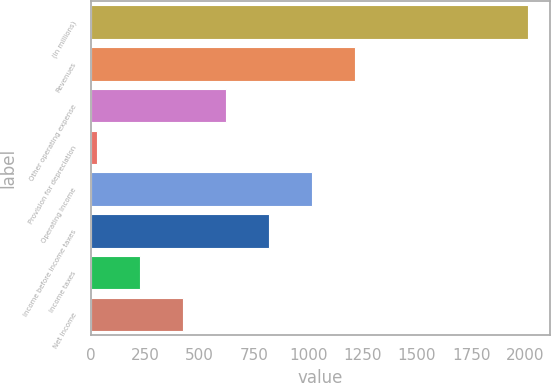<chart> <loc_0><loc_0><loc_500><loc_500><bar_chart><fcel>(In millions)<fcel>Revenues<fcel>Other operating expense<fcel>Provision for depreciation<fcel>Operating Income<fcel>Income before income taxes<fcel>Income taxes<fcel>Net Income<nl><fcel>2010<fcel>1216.8<fcel>621.9<fcel>27<fcel>1018.5<fcel>820.2<fcel>225.3<fcel>423.6<nl></chart> 